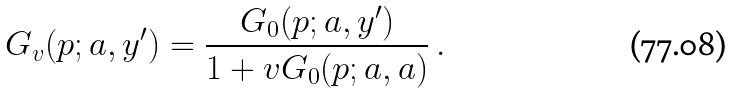<formula> <loc_0><loc_0><loc_500><loc_500>G _ { v } ( p ; a , y ^ { \prime } ) = \frac { G _ { 0 } ( p ; a , y ^ { \prime } ) } { 1 + v G _ { 0 } ( p ; a , a ) } \, .</formula> 